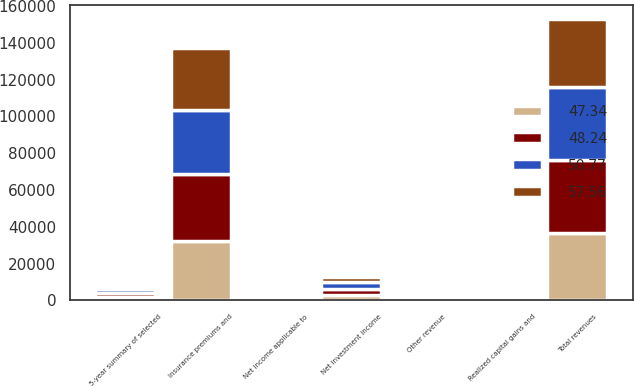<chart> <loc_0><loc_0><loc_500><loc_500><stacked_bar_chart><ecel><fcel>5-year summary of selected<fcel>Insurance premiums and<fcel>Other revenue<fcel>Net investment income<fcel>Realized capital gains and<fcel>Total revenues<fcel>Net income applicable to<nl><fcel>48.24<fcel>2018<fcel>36513<fcel>939<fcel>3240<fcel>877<fcel>39815<fcel>6.05<nl><fcel>50.77<fcel>2017<fcel>34678<fcel>883<fcel>3401<fcel>445<fcel>39407<fcel>8.49<nl><fcel>57.56<fcel>2016<fcel>33582<fcel>865<fcel>3042<fcel>90<fcel>37399<fcel>4.72<nl><fcel>47.34<fcel>2015<fcel>32467<fcel>863<fcel>3156<fcel>30<fcel>36516<fcel>5.12<nl></chart> 